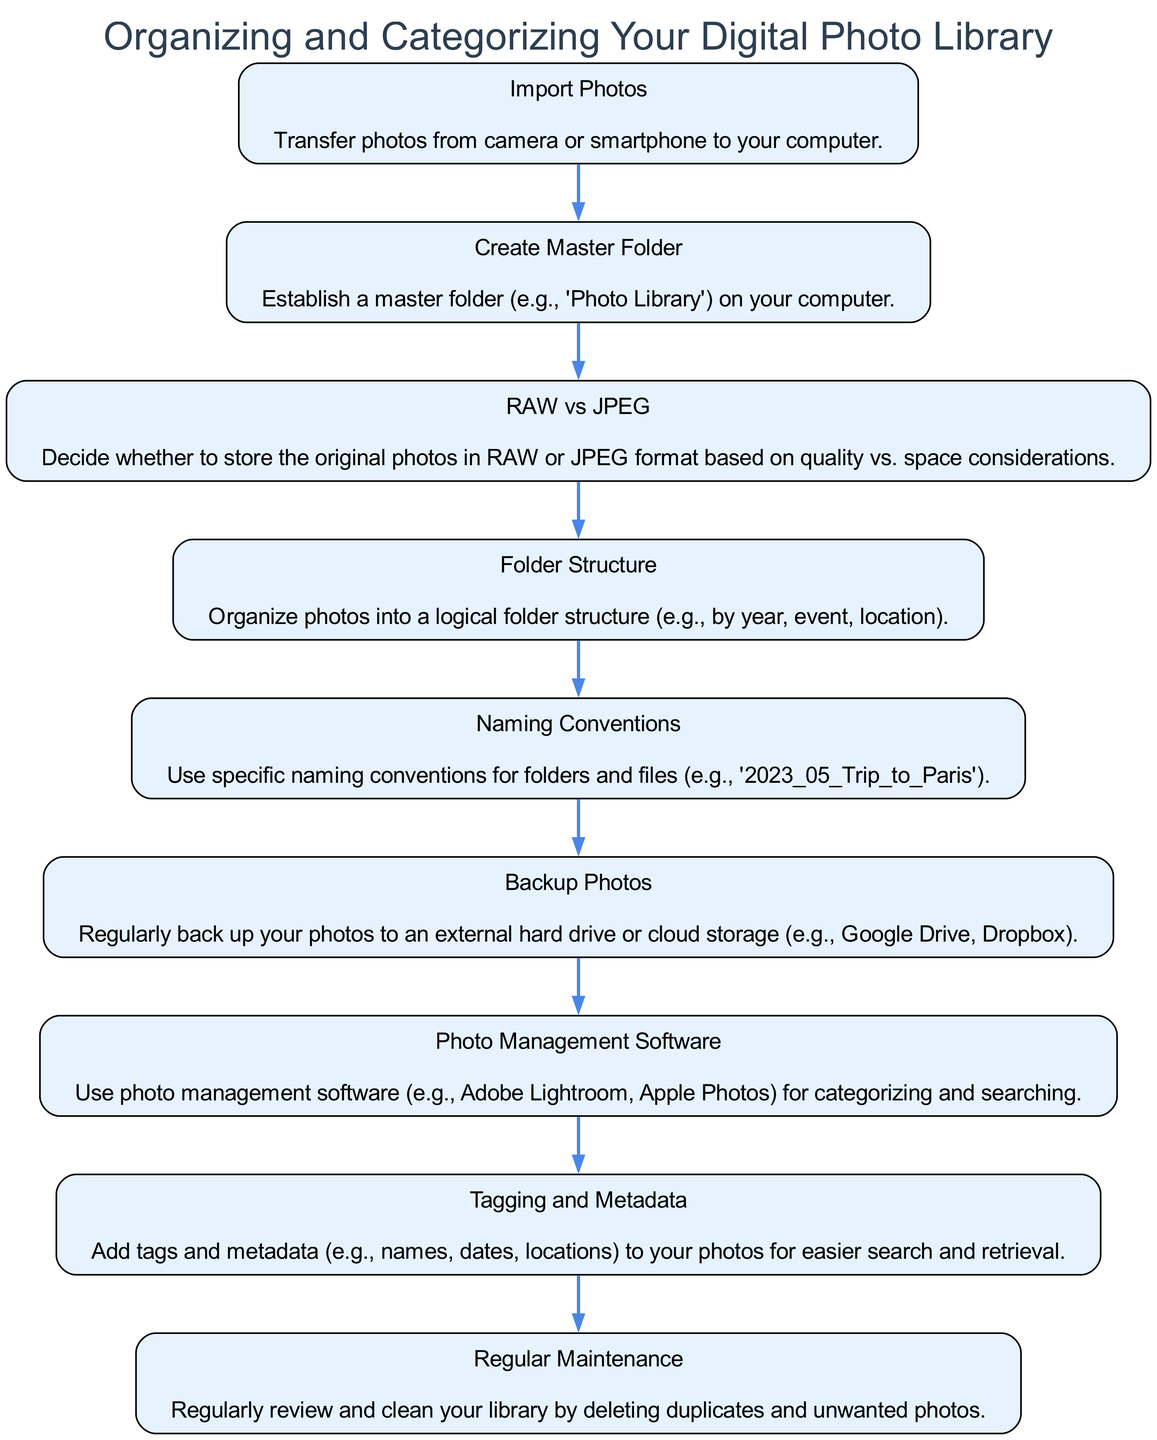What is the first block in the diagram? The first block listed in the diagram is "Import Photos," which is the starting point of the process.
Answer: Import Photos How many blocks are present in the diagram? The diagram contains a total of nine blocks, each representing a different aspect of organizing a digital photo library.
Answer: Nine What comes after "Create Master Folder"? The block that follows "Create Master Folder" is "RAW vs JPEG," indicating the next step after establishing the master folder.
Answer: RAW vs JPEG What is the purpose of "Backup Photos"? The "Backup Photos" block emphasizes the importance of regularly saving copies of your photos to prevent data loss.
Answer: Regularly back up your photos What is a suggested naming convention mentioned in the diagram? The suggested naming convention provided is '2023_05_Trip_to_Paris,' which exemplifies a systematic naming style for organizing files.
Answer: 2023_05_Trip_to_Paris Which block focuses on photo management software? The block titled "Photo Management Software" addresses using software applications like Adobe Lightroom or Apple Photos for better photo categorization.
Answer: Photo Management Software How does "Tagging and Metadata" help in photo organization? "Tagging and Metadata" facilitates easier search and retrieval of photos by adding relevant information such as names, dates, and locations for each image.
Answer: Easier search and retrieval What action should you take during "Regular Maintenance"? During "Regular Maintenance," you should review and clean your library, specifically by deleting duplicates and unwanted photos to keep it organized.
Answer: Deleting duplicates and unwanted photos Which block discusses folder structure? The block that addresses the organization of photos is "Folder Structure," where you can categorize images in a structured manner like by year, event, or location.
Answer: Folder Structure 